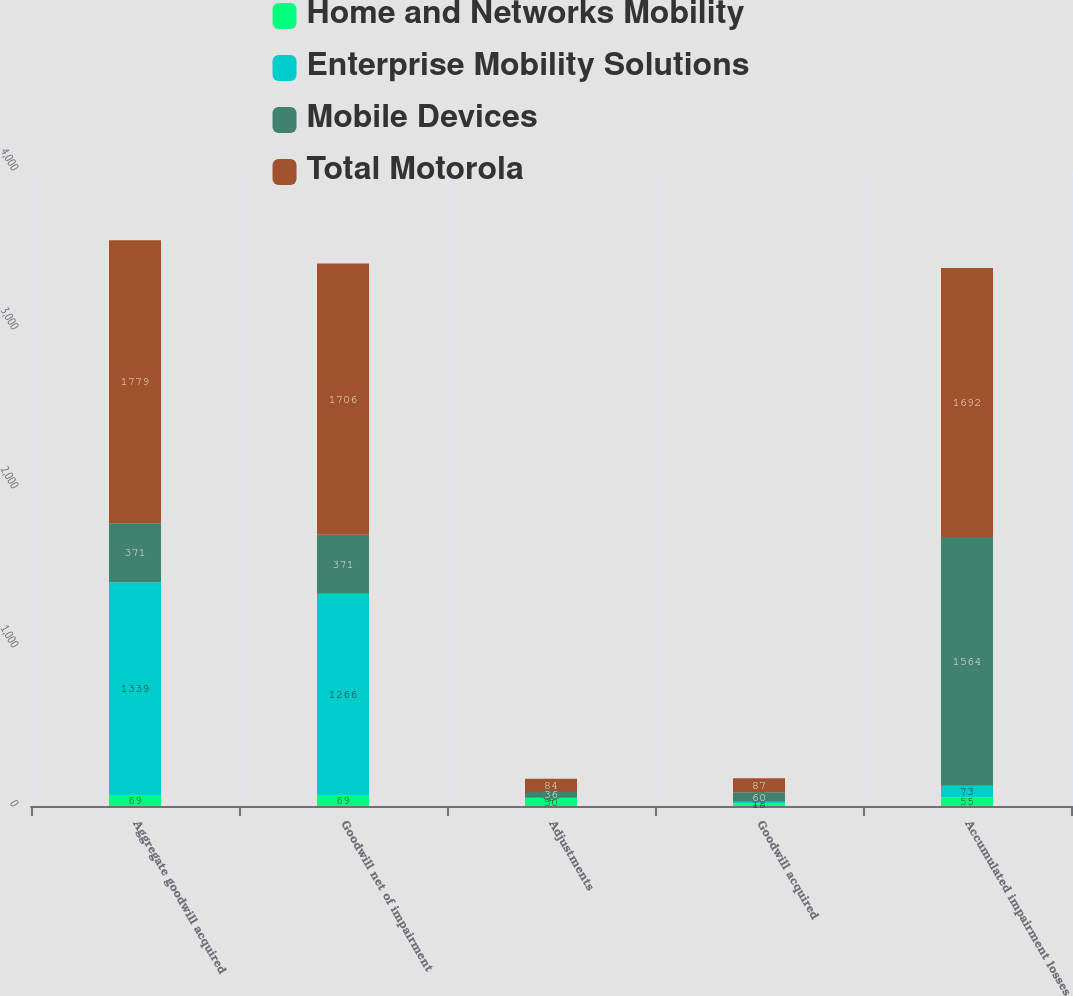Convert chart. <chart><loc_0><loc_0><loc_500><loc_500><stacked_bar_chart><ecel><fcel>Aggregate goodwill acquired<fcel>Goodwill net of impairment<fcel>Adjustments<fcel>Goodwill acquired<fcel>Accumulated impairment losses<nl><fcel>Home and Networks Mobility<fcel>69<fcel>69<fcel>50<fcel>15<fcel>55<nl><fcel>Enterprise Mobility Solutions<fcel>1339<fcel>1266<fcel>2<fcel>12<fcel>73<nl><fcel>Mobile Devices<fcel>371<fcel>371<fcel>36<fcel>60<fcel>1564<nl><fcel>Total Motorola<fcel>1779<fcel>1706<fcel>84<fcel>87<fcel>1692<nl></chart> 